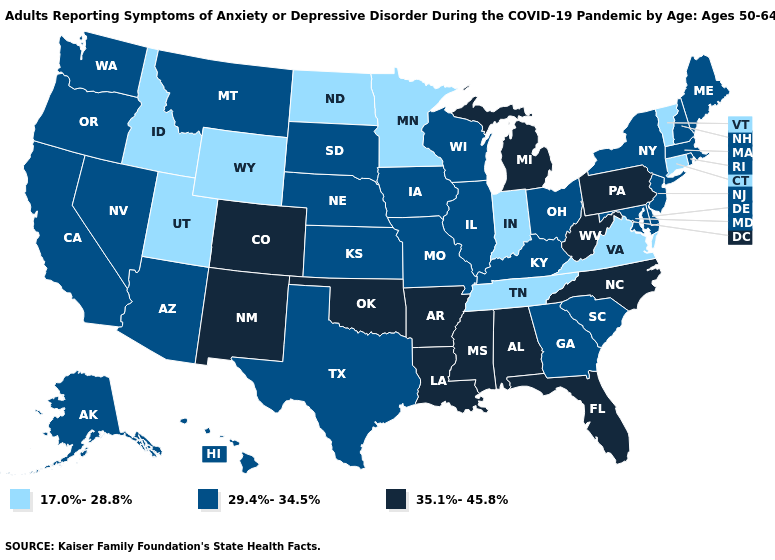Does Wyoming have the lowest value in the West?
Write a very short answer. Yes. Among the states that border New York , which have the highest value?
Quick response, please. Pennsylvania. What is the lowest value in states that border Rhode Island?
Answer briefly. 17.0%-28.8%. What is the highest value in states that border Colorado?
Be succinct. 35.1%-45.8%. Name the states that have a value in the range 29.4%-34.5%?
Short answer required. Alaska, Arizona, California, Delaware, Georgia, Hawaii, Illinois, Iowa, Kansas, Kentucky, Maine, Maryland, Massachusetts, Missouri, Montana, Nebraska, Nevada, New Hampshire, New Jersey, New York, Ohio, Oregon, Rhode Island, South Carolina, South Dakota, Texas, Washington, Wisconsin. What is the lowest value in the South?
Be succinct. 17.0%-28.8%. What is the lowest value in the MidWest?
Concise answer only. 17.0%-28.8%. Name the states that have a value in the range 29.4%-34.5%?
Quick response, please. Alaska, Arizona, California, Delaware, Georgia, Hawaii, Illinois, Iowa, Kansas, Kentucky, Maine, Maryland, Massachusetts, Missouri, Montana, Nebraska, Nevada, New Hampshire, New Jersey, New York, Ohio, Oregon, Rhode Island, South Carolina, South Dakota, Texas, Washington, Wisconsin. Name the states that have a value in the range 17.0%-28.8%?
Answer briefly. Connecticut, Idaho, Indiana, Minnesota, North Dakota, Tennessee, Utah, Vermont, Virginia, Wyoming. Name the states that have a value in the range 29.4%-34.5%?
Short answer required. Alaska, Arizona, California, Delaware, Georgia, Hawaii, Illinois, Iowa, Kansas, Kentucky, Maine, Maryland, Massachusetts, Missouri, Montana, Nebraska, Nevada, New Hampshire, New Jersey, New York, Ohio, Oregon, Rhode Island, South Carolina, South Dakota, Texas, Washington, Wisconsin. Which states have the lowest value in the USA?
Quick response, please. Connecticut, Idaho, Indiana, Minnesota, North Dakota, Tennessee, Utah, Vermont, Virginia, Wyoming. Which states have the highest value in the USA?
Concise answer only. Alabama, Arkansas, Colorado, Florida, Louisiana, Michigan, Mississippi, New Mexico, North Carolina, Oklahoma, Pennsylvania, West Virginia. Does West Virginia have a lower value than Minnesota?
Write a very short answer. No. Name the states that have a value in the range 35.1%-45.8%?
Answer briefly. Alabama, Arkansas, Colorado, Florida, Louisiana, Michigan, Mississippi, New Mexico, North Carolina, Oklahoma, Pennsylvania, West Virginia. Name the states that have a value in the range 35.1%-45.8%?
Answer briefly. Alabama, Arkansas, Colorado, Florida, Louisiana, Michigan, Mississippi, New Mexico, North Carolina, Oklahoma, Pennsylvania, West Virginia. 